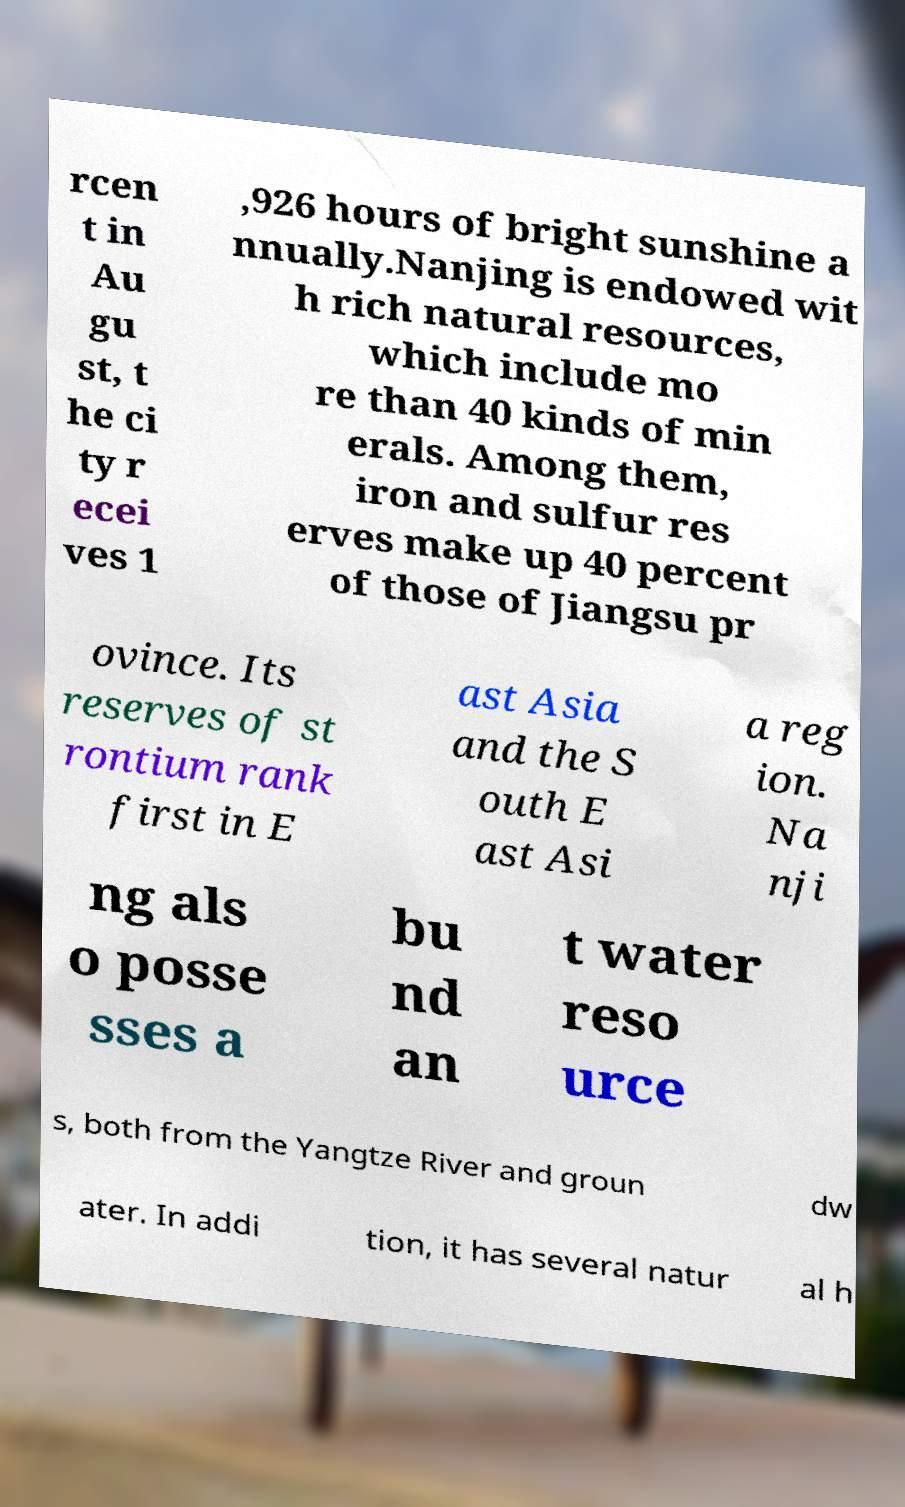I need the written content from this picture converted into text. Can you do that? rcen t in Au gu st, t he ci ty r ecei ves 1 ,926 hours of bright sunshine a nnually.Nanjing is endowed wit h rich natural resources, which include mo re than 40 kinds of min erals. Among them, iron and sulfur res erves make up 40 percent of those of Jiangsu pr ovince. Its reserves of st rontium rank first in E ast Asia and the S outh E ast Asi a reg ion. Na nji ng als o posse sses a bu nd an t water reso urce s, both from the Yangtze River and groun dw ater. In addi tion, it has several natur al h 